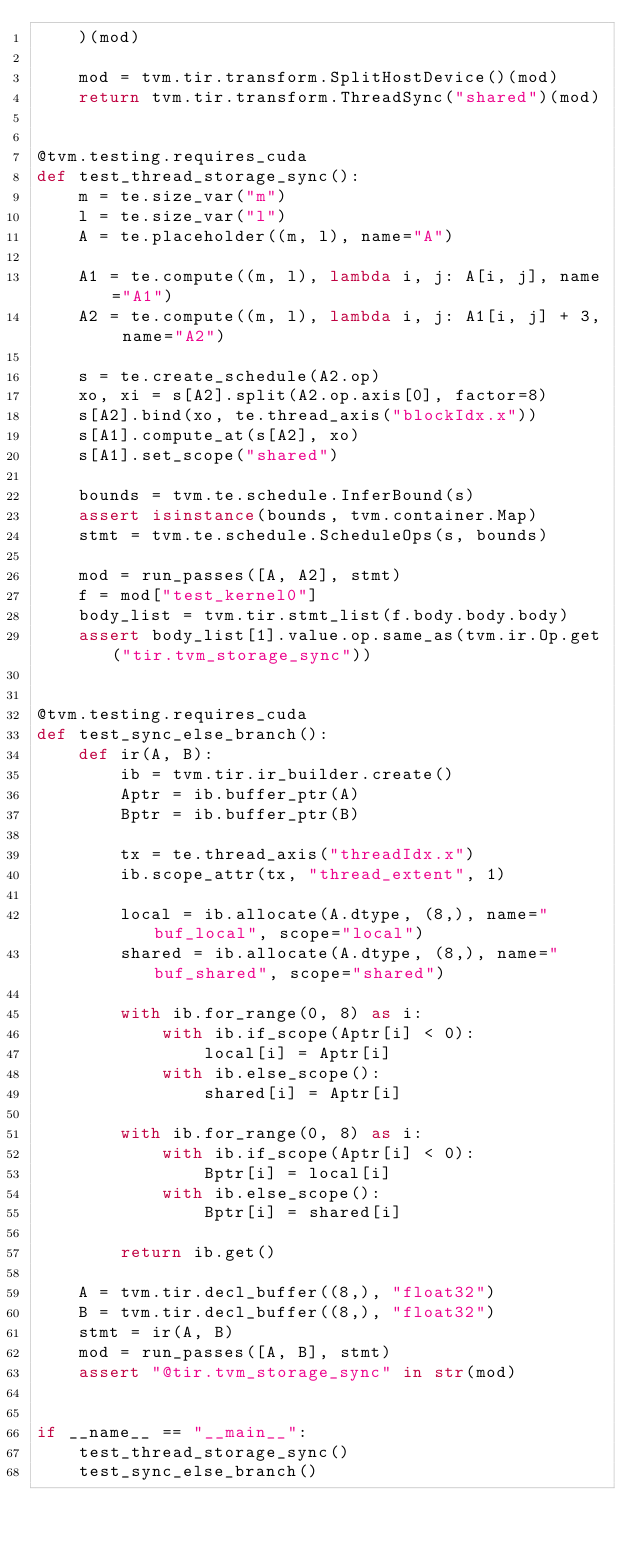<code> <loc_0><loc_0><loc_500><loc_500><_Python_>    )(mod)

    mod = tvm.tir.transform.SplitHostDevice()(mod)
    return tvm.tir.transform.ThreadSync("shared")(mod)


@tvm.testing.requires_cuda
def test_thread_storage_sync():
    m = te.size_var("m")
    l = te.size_var("l")
    A = te.placeholder((m, l), name="A")

    A1 = te.compute((m, l), lambda i, j: A[i, j], name="A1")
    A2 = te.compute((m, l), lambda i, j: A1[i, j] + 3, name="A2")

    s = te.create_schedule(A2.op)
    xo, xi = s[A2].split(A2.op.axis[0], factor=8)
    s[A2].bind(xo, te.thread_axis("blockIdx.x"))
    s[A1].compute_at(s[A2], xo)
    s[A1].set_scope("shared")

    bounds = tvm.te.schedule.InferBound(s)
    assert isinstance(bounds, tvm.container.Map)
    stmt = tvm.te.schedule.ScheduleOps(s, bounds)

    mod = run_passes([A, A2], stmt)
    f = mod["test_kernel0"]
    body_list = tvm.tir.stmt_list(f.body.body.body)
    assert body_list[1].value.op.same_as(tvm.ir.Op.get("tir.tvm_storage_sync"))


@tvm.testing.requires_cuda
def test_sync_else_branch():
    def ir(A, B):
        ib = tvm.tir.ir_builder.create()
        Aptr = ib.buffer_ptr(A)
        Bptr = ib.buffer_ptr(B)

        tx = te.thread_axis("threadIdx.x")
        ib.scope_attr(tx, "thread_extent", 1)

        local = ib.allocate(A.dtype, (8,), name="buf_local", scope="local")
        shared = ib.allocate(A.dtype, (8,), name="buf_shared", scope="shared")

        with ib.for_range(0, 8) as i:
            with ib.if_scope(Aptr[i] < 0):
                local[i] = Aptr[i]
            with ib.else_scope():
                shared[i] = Aptr[i]

        with ib.for_range(0, 8) as i:
            with ib.if_scope(Aptr[i] < 0):
                Bptr[i] = local[i]
            with ib.else_scope():
                Bptr[i] = shared[i]

        return ib.get()

    A = tvm.tir.decl_buffer((8,), "float32")
    B = tvm.tir.decl_buffer((8,), "float32")
    stmt = ir(A, B)
    mod = run_passes([A, B], stmt)
    assert "@tir.tvm_storage_sync" in str(mod)


if __name__ == "__main__":
    test_thread_storage_sync()
    test_sync_else_branch()
</code> 